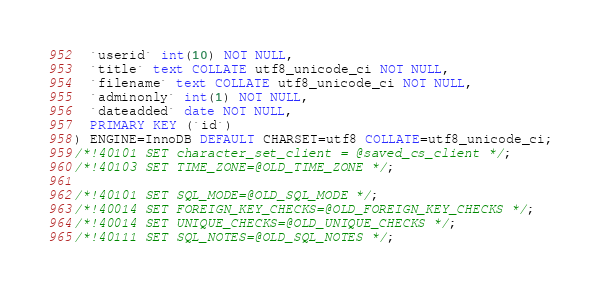Convert code to text. <code><loc_0><loc_0><loc_500><loc_500><_SQL_>  `userid` int(10) NOT NULL,
  `title` text COLLATE utf8_unicode_ci NOT NULL,
  `filename` text COLLATE utf8_unicode_ci NOT NULL,
  `adminonly` int(1) NOT NULL,
  `dateadded` date NOT NULL,
  PRIMARY KEY (`id`)
) ENGINE=InnoDB DEFAULT CHARSET=utf8 COLLATE=utf8_unicode_ci;
/*!40101 SET character_set_client = @saved_cs_client */;
/*!40103 SET TIME_ZONE=@OLD_TIME_ZONE */;

/*!40101 SET SQL_MODE=@OLD_SQL_MODE */;
/*!40014 SET FOREIGN_KEY_CHECKS=@OLD_FOREIGN_KEY_CHECKS */;
/*!40014 SET UNIQUE_CHECKS=@OLD_UNIQUE_CHECKS */;
/*!40111 SET SQL_NOTES=@OLD_SQL_NOTES */;

</code> 